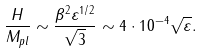<formula> <loc_0><loc_0><loc_500><loc_500>\frac { H } { M _ { p l } } \sim \frac { \beta ^ { 2 } \varepsilon ^ { 1 / 2 } } { \sqrt { 3 } } \sim 4 \cdot 1 0 ^ { - 4 } \sqrt { \varepsilon } .</formula> 